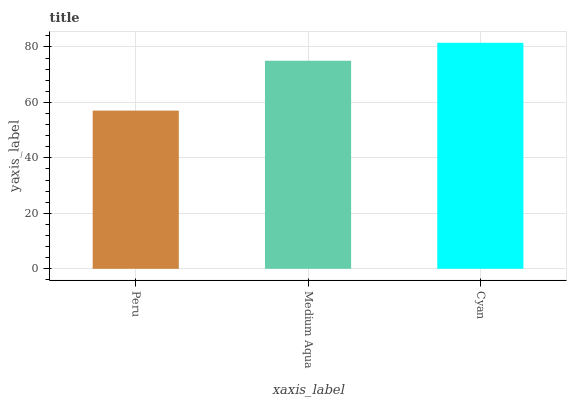Is Peru the minimum?
Answer yes or no. Yes. Is Cyan the maximum?
Answer yes or no. Yes. Is Medium Aqua the minimum?
Answer yes or no. No. Is Medium Aqua the maximum?
Answer yes or no. No. Is Medium Aqua greater than Peru?
Answer yes or no. Yes. Is Peru less than Medium Aqua?
Answer yes or no. Yes. Is Peru greater than Medium Aqua?
Answer yes or no. No. Is Medium Aqua less than Peru?
Answer yes or no. No. Is Medium Aqua the high median?
Answer yes or no. Yes. Is Medium Aqua the low median?
Answer yes or no. Yes. Is Peru the high median?
Answer yes or no. No. Is Cyan the low median?
Answer yes or no. No. 